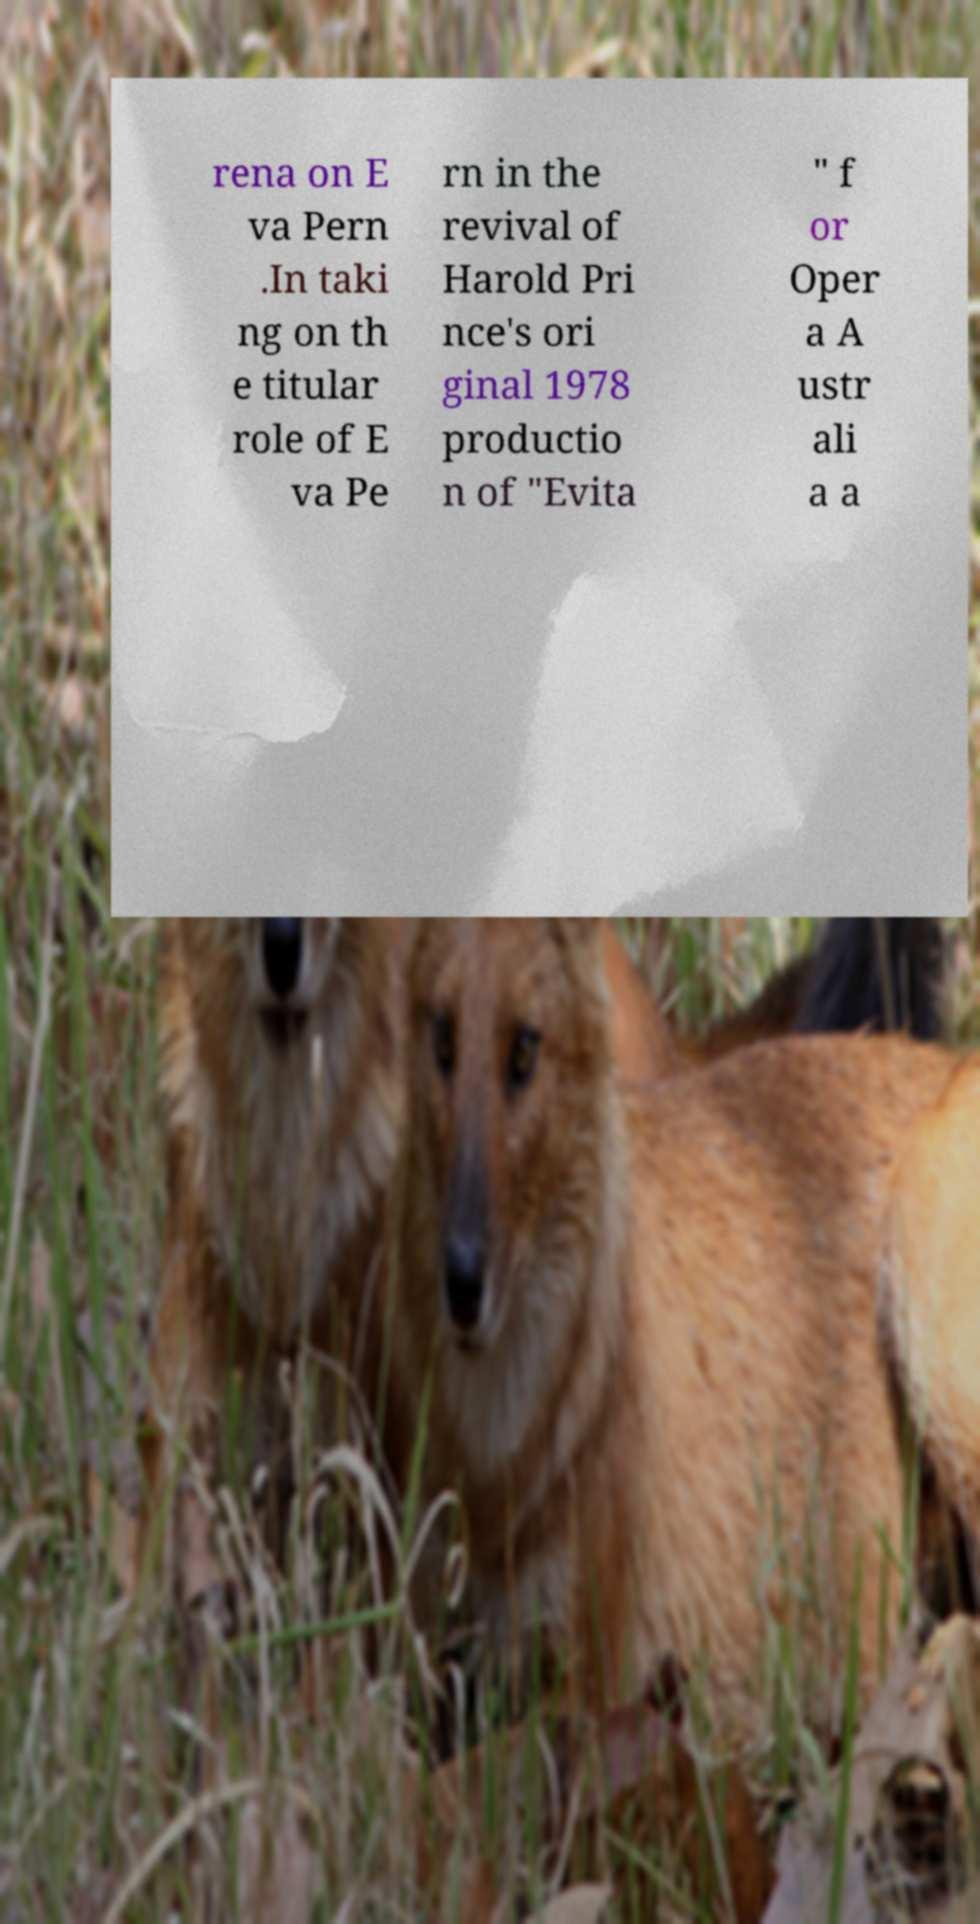Can you accurately transcribe the text from the provided image for me? rena on E va Pern .In taki ng on th e titular role of E va Pe rn in the revival of Harold Pri nce's ori ginal 1978 productio n of "Evita " f or Oper a A ustr ali a a 